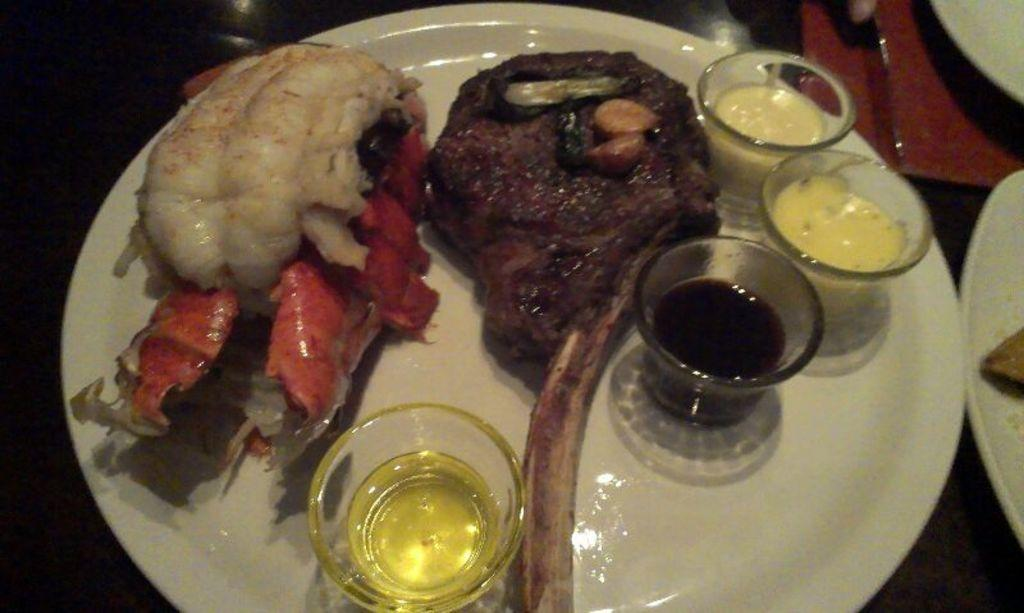What is on the plate in the image? There is food on the plate in the image. How many cups are present on the plate? There are four cups present on the plate. What type of chess piece is depicted on the plate? There is no chess piece present on the plate; it contains food and cups. 